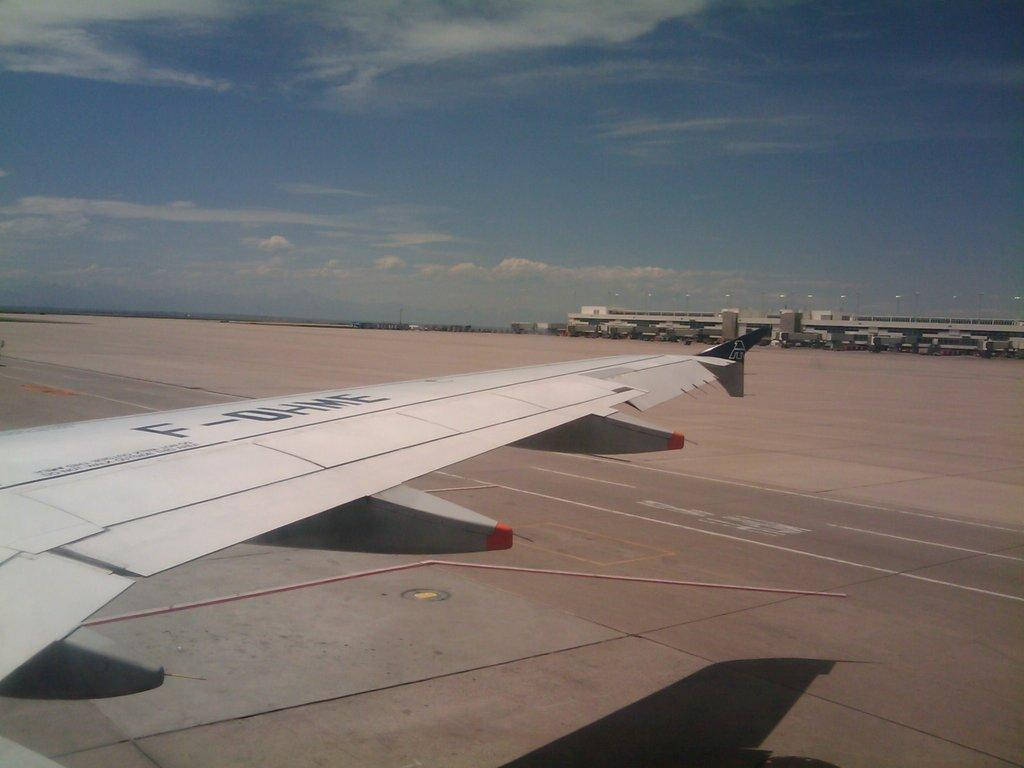What is located on the runway in the image? There is a wing of an airplane on the runway in the image. What can be seen in the background of the image? There is an airport in the background of the image. What is visible in the sky in the image? The sky is visible in the image, and clouds are present. What type of potato is being used to shock the top of the airplane wing in the image? There is no potato or shocking activity present in the image. 